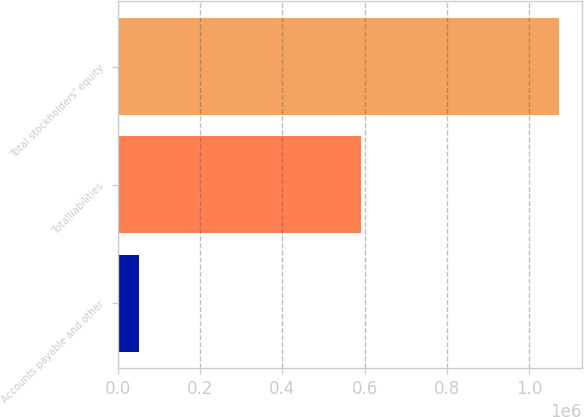<chart> <loc_0><loc_0><loc_500><loc_500><bar_chart><fcel>Accounts payable and other<fcel>Totalliabilities<fcel>Total stockholders' equity<nl><fcel>52296<fcel>589898<fcel>1.073e+06<nl></chart> 